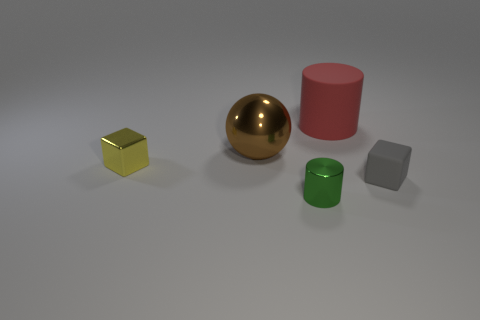What is the color of the shiny thing that is both on the right side of the small yellow block and in front of the brown sphere?
Offer a very short reply. Green. What number of other things are the same size as the red cylinder?
Your answer should be compact. 1. There is a brown metal sphere; is its size the same as the block on the right side of the green shiny cylinder?
Your response must be concise. No. The matte cylinder that is the same size as the brown thing is what color?
Offer a very short reply. Red. How big is the yellow metallic cube?
Your answer should be very brief. Small. Is the material of the large object that is in front of the red rubber thing the same as the red object?
Offer a very short reply. No. Is the small yellow metal object the same shape as the green thing?
Keep it short and to the point. No. The tiny metal object that is in front of the tiny object to the right of the rubber object behind the large brown object is what shape?
Give a very brief answer. Cylinder. Does the big thing left of the large matte object have the same shape as the small thing behind the gray rubber block?
Offer a terse response. No. Is there a green cylinder that has the same material as the yellow cube?
Make the answer very short. Yes. 